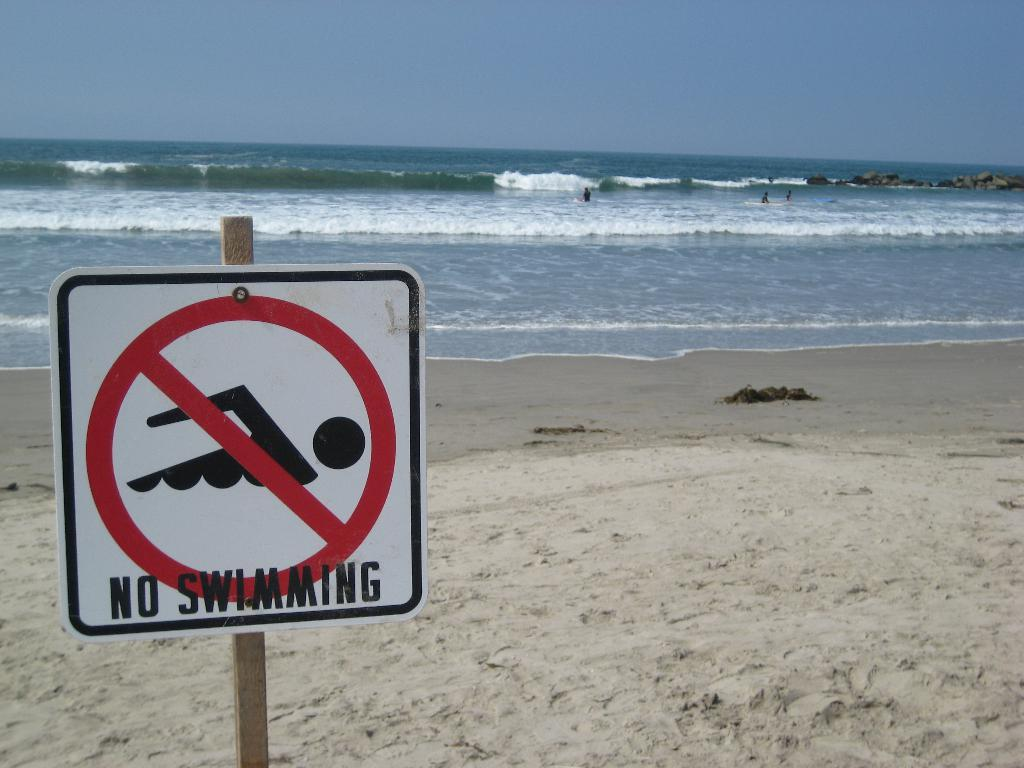<image>
Summarize the visual content of the image. a red, black and white sign that reads no swimming on the bottom of it. 